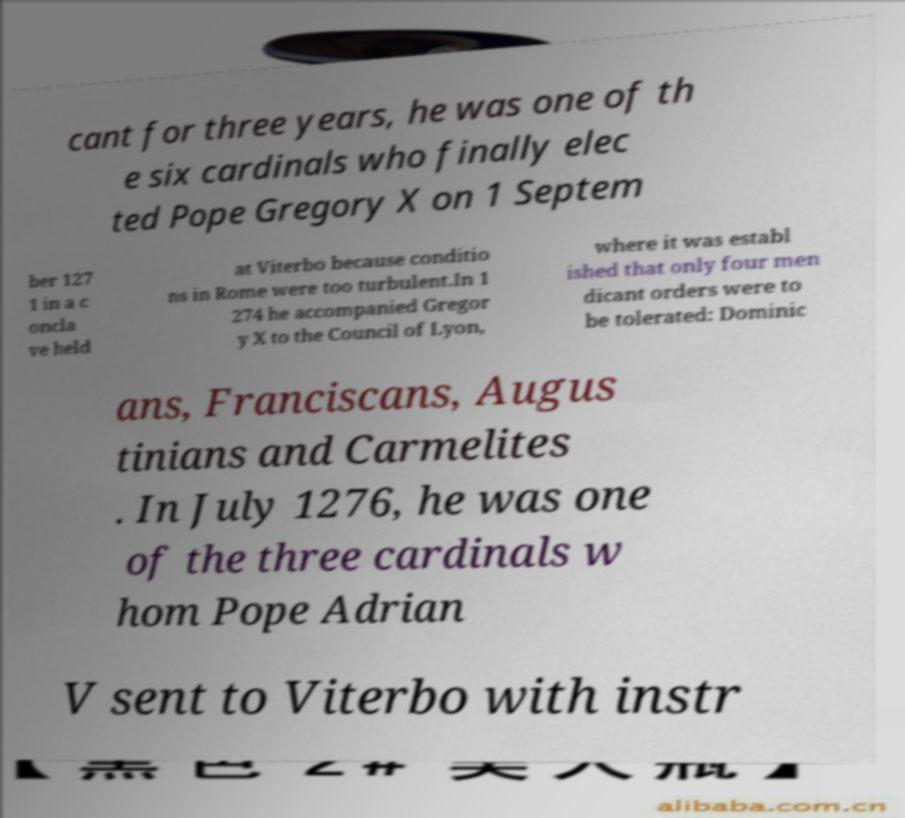Please identify and transcribe the text found in this image. cant for three years, he was one of th e six cardinals who finally elec ted Pope Gregory X on 1 Septem ber 127 1 in a c oncla ve held at Viterbo because conditio ns in Rome were too turbulent.In 1 274 he accompanied Gregor y X to the Council of Lyon, where it was establ ished that only four men dicant orders were to be tolerated: Dominic ans, Franciscans, Augus tinians and Carmelites . In July 1276, he was one of the three cardinals w hom Pope Adrian V sent to Viterbo with instr 